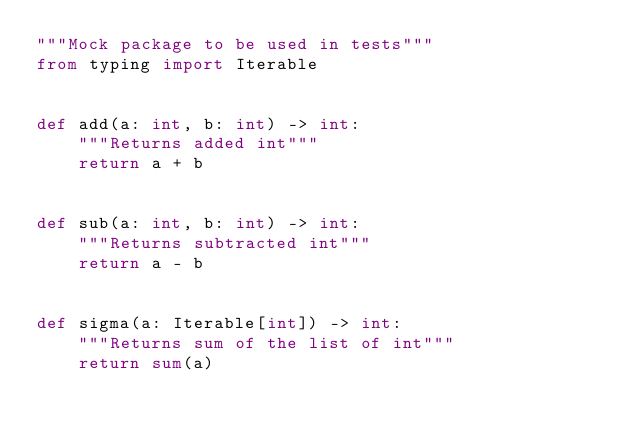Convert code to text. <code><loc_0><loc_0><loc_500><loc_500><_Python_>"""Mock package to be used in tests"""
from typing import Iterable


def add(a: int, b: int) -> int:
    """Returns added int"""
    return a + b


def sub(a: int, b: int) -> int:
    """Returns subtracted int"""
    return a - b


def sigma(a: Iterable[int]) -> int:
    """Returns sum of the list of int"""
    return sum(a)
</code> 